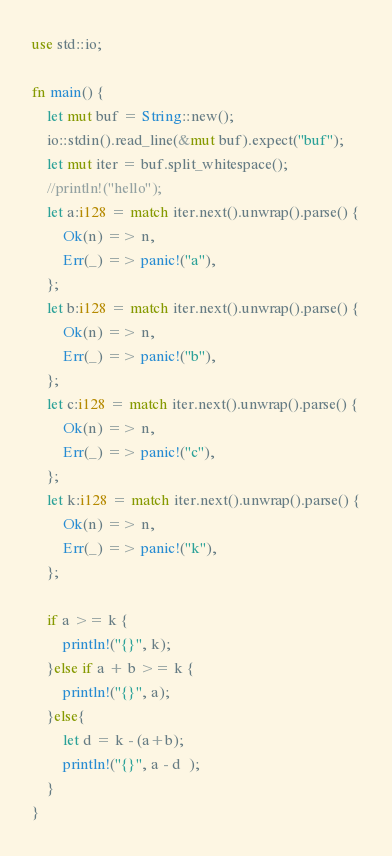<code> <loc_0><loc_0><loc_500><loc_500><_Rust_>use std::io;

fn main() {
	let mut buf = String::new();
	io::stdin().read_line(&mut buf).expect("buf");
	let mut iter = buf.split_whitespace();
	//println!("hello");
	let a:i128 = match iter.next().unwrap().parse() {
		Ok(n) => n,
		Err(_) => panic!("a"),
	};
	let b:i128 = match iter.next().unwrap().parse() {
		Ok(n) => n,
		Err(_) => panic!("b"),
	};
	let c:i128 = match iter.next().unwrap().parse() {
		Ok(n) => n,
		Err(_) => panic!("c"),
	};
	let k:i128 = match iter.next().unwrap().parse() {
		Ok(n) => n,
		Err(_) => panic!("k"),
	};

	if a >= k {
		println!("{}", k);
	}else if a + b >= k {
		println!("{}", a);
	}else{
		let d = k - (a+b);
	 	println!("{}", a - d  );
	}
}</code> 